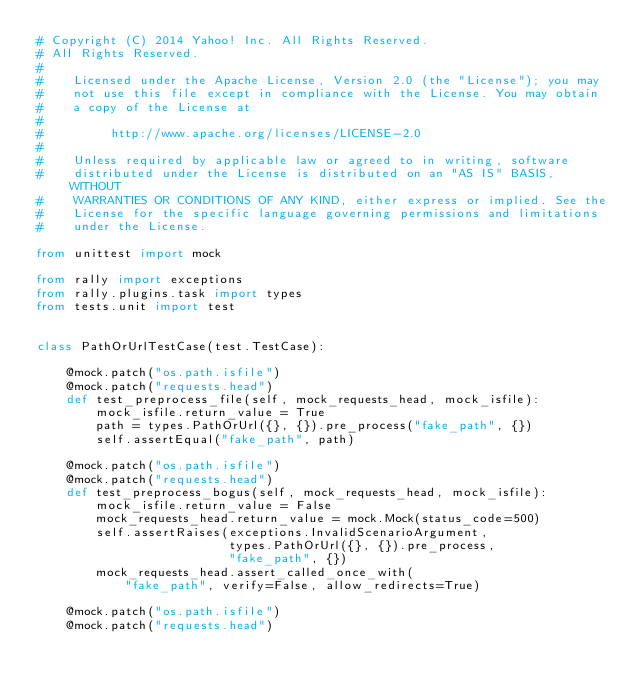<code> <loc_0><loc_0><loc_500><loc_500><_Python_># Copyright (C) 2014 Yahoo! Inc. All Rights Reserved.
# All Rights Reserved.
#
#    Licensed under the Apache License, Version 2.0 (the "License"); you may
#    not use this file except in compliance with the License. You may obtain
#    a copy of the License at
#
#         http://www.apache.org/licenses/LICENSE-2.0
#
#    Unless required by applicable law or agreed to in writing, software
#    distributed under the License is distributed on an "AS IS" BASIS, WITHOUT
#    WARRANTIES OR CONDITIONS OF ANY KIND, either express or implied. See the
#    License for the specific language governing permissions and limitations
#    under the License.

from unittest import mock

from rally import exceptions
from rally.plugins.task import types
from tests.unit import test


class PathOrUrlTestCase(test.TestCase):

    @mock.patch("os.path.isfile")
    @mock.patch("requests.head")
    def test_preprocess_file(self, mock_requests_head, mock_isfile):
        mock_isfile.return_value = True
        path = types.PathOrUrl({}, {}).pre_process("fake_path", {})
        self.assertEqual("fake_path", path)

    @mock.patch("os.path.isfile")
    @mock.patch("requests.head")
    def test_preprocess_bogus(self, mock_requests_head, mock_isfile):
        mock_isfile.return_value = False
        mock_requests_head.return_value = mock.Mock(status_code=500)
        self.assertRaises(exceptions.InvalidScenarioArgument,
                          types.PathOrUrl({}, {}).pre_process,
                          "fake_path", {})
        mock_requests_head.assert_called_once_with(
            "fake_path", verify=False, allow_redirects=True)

    @mock.patch("os.path.isfile")
    @mock.patch("requests.head")</code> 